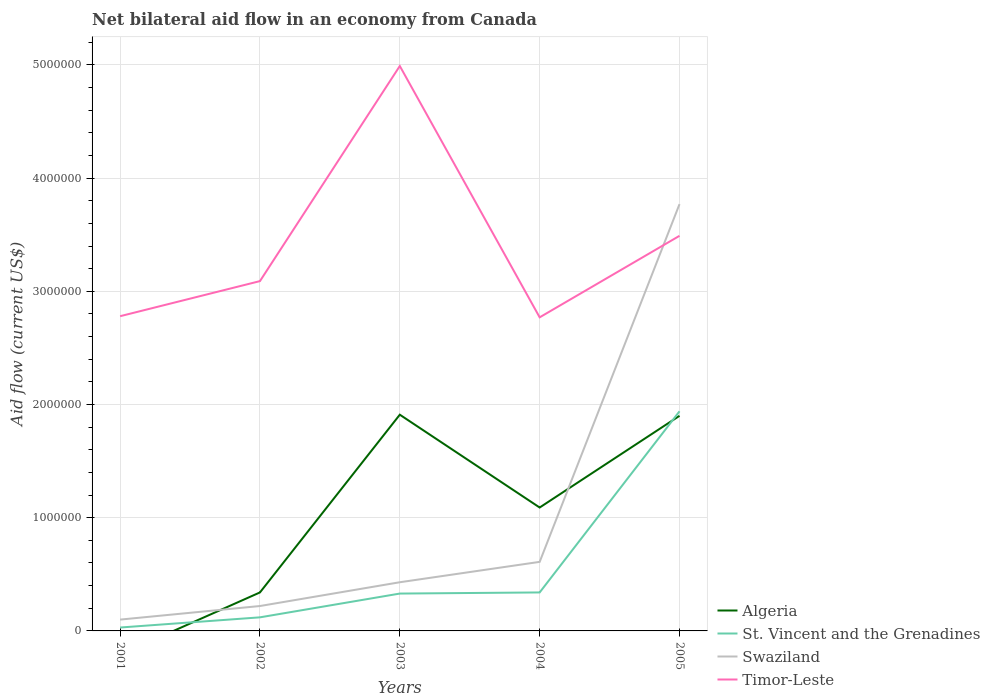How many different coloured lines are there?
Provide a short and direct response. 4. Is the number of lines equal to the number of legend labels?
Provide a short and direct response. No. Across all years, what is the maximum net bilateral aid flow in Swaziland?
Provide a succinct answer. 1.00e+05. What is the total net bilateral aid flow in St. Vincent and the Grenadines in the graph?
Offer a terse response. -3.10e+05. What is the difference between the highest and the second highest net bilateral aid flow in Algeria?
Your response must be concise. 1.91e+06. What is the difference between the highest and the lowest net bilateral aid flow in St. Vincent and the Grenadines?
Offer a very short reply. 1. Is the net bilateral aid flow in Timor-Leste strictly greater than the net bilateral aid flow in Algeria over the years?
Your answer should be compact. No. How many lines are there?
Make the answer very short. 4. How many years are there in the graph?
Offer a very short reply. 5. What is the difference between two consecutive major ticks on the Y-axis?
Give a very brief answer. 1.00e+06. Does the graph contain any zero values?
Provide a succinct answer. Yes. How many legend labels are there?
Give a very brief answer. 4. How are the legend labels stacked?
Ensure brevity in your answer.  Vertical. What is the title of the graph?
Make the answer very short. Net bilateral aid flow in an economy from Canada. Does "Cabo Verde" appear as one of the legend labels in the graph?
Provide a succinct answer. No. What is the Aid flow (current US$) in St. Vincent and the Grenadines in 2001?
Give a very brief answer. 3.00e+04. What is the Aid flow (current US$) of Swaziland in 2001?
Your answer should be compact. 1.00e+05. What is the Aid flow (current US$) in Timor-Leste in 2001?
Your answer should be very brief. 2.78e+06. What is the Aid flow (current US$) in Timor-Leste in 2002?
Your answer should be compact. 3.09e+06. What is the Aid flow (current US$) in Algeria in 2003?
Offer a very short reply. 1.91e+06. What is the Aid flow (current US$) of St. Vincent and the Grenadines in 2003?
Provide a short and direct response. 3.30e+05. What is the Aid flow (current US$) in Swaziland in 2003?
Your answer should be very brief. 4.30e+05. What is the Aid flow (current US$) in Timor-Leste in 2003?
Give a very brief answer. 4.99e+06. What is the Aid flow (current US$) of Algeria in 2004?
Give a very brief answer. 1.09e+06. What is the Aid flow (current US$) of St. Vincent and the Grenadines in 2004?
Provide a succinct answer. 3.40e+05. What is the Aid flow (current US$) in Swaziland in 2004?
Your answer should be very brief. 6.10e+05. What is the Aid flow (current US$) in Timor-Leste in 2004?
Make the answer very short. 2.77e+06. What is the Aid flow (current US$) in Algeria in 2005?
Give a very brief answer. 1.90e+06. What is the Aid flow (current US$) of St. Vincent and the Grenadines in 2005?
Your answer should be very brief. 1.94e+06. What is the Aid flow (current US$) in Swaziland in 2005?
Your response must be concise. 3.77e+06. What is the Aid flow (current US$) in Timor-Leste in 2005?
Your answer should be very brief. 3.49e+06. Across all years, what is the maximum Aid flow (current US$) of Algeria?
Provide a short and direct response. 1.91e+06. Across all years, what is the maximum Aid flow (current US$) of St. Vincent and the Grenadines?
Offer a very short reply. 1.94e+06. Across all years, what is the maximum Aid flow (current US$) of Swaziland?
Provide a short and direct response. 3.77e+06. Across all years, what is the maximum Aid flow (current US$) in Timor-Leste?
Ensure brevity in your answer.  4.99e+06. Across all years, what is the minimum Aid flow (current US$) of Algeria?
Offer a terse response. 0. Across all years, what is the minimum Aid flow (current US$) of St. Vincent and the Grenadines?
Your answer should be very brief. 3.00e+04. Across all years, what is the minimum Aid flow (current US$) in Swaziland?
Offer a very short reply. 1.00e+05. Across all years, what is the minimum Aid flow (current US$) of Timor-Leste?
Your answer should be compact. 2.77e+06. What is the total Aid flow (current US$) in Algeria in the graph?
Offer a very short reply. 5.24e+06. What is the total Aid flow (current US$) in St. Vincent and the Grenadines in the graph?
Keep it short and to the point. 2.76e+06. What is the total Aid flow (current US$) of Swaziland in the graph?
Your answer should be very brief. 5.13e+06. What is the total Aid flow (current US$) in Timor-Leste in the graph?
Provide a short and direct response. 1.71e+07. What is the difference between the Aid flow (current US$) of Timor-Leste in 2001 and that in 2002?
Ensure brevity in your answer.  -3.10e+05. What is the difference between the Aid flow (current US$) of Swaziland in 2001 and that in 2003?
Give a very brief answer. -3.30e+05. What is the difference between the Aid flow (current US$) in Timor-Leste in 2001 and that in 2003?
Your answer should be compact. -2.21e+06. What is the difference between the Aid flow (current US$) in St. Vincent and the Grenadines in 2001 and that in 2004?
Your answer should be compact. -3.10e+05. What is the difference between the Aid flow (current US$) of Swaziland in 2001 and that in 2004?
Offer a terse response. -5.10e+05. What is the difference between the Aid flow (current US$) of St. Vincent and the Grenadines in 2001 and that in 2005?
Your response must be concise. -1.91e+06. What is the difference between the Aid flow (current US$) of Swaziland in 2001 and that in 2005?
Your answer should be very brief. -3.67e+06. What is the difference between the Aid flow (current US$) in Timor-Leste in 2001 and that in 2005?
Offer a terse response. -7.10e+05. What is the difference between the Aid flow (current US$) of Algeria in 2002 and that in 2003?
Offer a very short reply. -1.57e+06. What is the difference between the Aid flow (current US$) in Timor-Leste in 2002 and that in 2003?
Keep it short and to the point. -1.90e+06. What is the difference between the Aid flow (current US$) in Algeria in 2002 and that in 2004?
Your answer should be compact. -7.50e+05. What is the difference between the Aid flow (current US$) of Swaziland in 2002 and that in 2004?
Ensure brevity in your answer.  -3.90e+05. What is the difference between the Aid flow (current US$) in Algeria in 2002 and that in 2005?
Your answer should be compact. -1.56e+06. What is the difference between the Aid flow (current US$) of St. Vincent and the Grenadines in 2002 and that in 2005?
Ensure brevity in your answer.  -1.82e+06. What is the difference between the Aid flow (current US$) of Swaziland in 2002 and that in 2005?
Make the answer very short. -3.55e+06. What is the difference between the Aid flow (current US$) in Timor-Leste in 2002 and that in 2005?
Your response must be concise. -4.00e+05. What is the difference between the Aid flow (current US$) in Algeria in 2003 and that in 2004?
Provide a short and direct response. 8.20e+05. What is the difference between the Aid flow (current US$) of Timor-Leste in 2003 and that in 2004?
Offer a very short reply. 2.22e+06. What is the difference between the Aid flow (current US$) in Algeria in 2003 and that in 2005?
Make the answer very short. 10000. What is the difference between the Aid flow (current US$) of St. Vincent and the Grenadines in 2003 and that in 2005?
Your answer should be very brief. -1.61e+06. What is the difference between the Aid flow (current US$) of Swaziland in 2003 and that in 2005?
Your answer should be very brief. -3.34e+06. What is the difference between the Aid flow (current US$) of Timor-Leste in 2003 and that in 2005?
Make the answer very short. 1.50e+06. What is the difference between the Aid flow (current US$) of Algeria in 2004 and that in 2005?
Give a very brief answer. -8.10e+05. What is the difference between the Aid flow (current US$) in St. Vincent and the Grenadines in 2004 and that in 2005?
Your response must be concise. -1.60e+06. What is the difference between the Aid flow (current US$) of Swaziland in 2004 and that in 2005?
Offer a very short reply. -3.16e+06. What is the difference between the Aid flow (current US$) of Timor-Leste in 2004 and that in 2005?
Your answer should be very brief. -7.20e+05. What is the difference between the Aid flow (current US$) in St. Vincent and the Grenadines in 2001 and the Aid flow (current US$) in Timor-Leste in 2002?
Provide a short and direct response. -3.06e+06. What is the difference between the Aid flow (current US$) in Swaziland in 2001 and the Aid flow (current US$) in Timor-Leste in 2002?
Ensure brevity in your answer.  -2.99e+06. What is the difference between the Aid flow (current US$) of St. Vincent and the Grenadines in 2001 and the Aid flow (current US$) of Swaziland in 2003?
Keep it short and to the point. -4.00e+05. What is the difference between the Aid flow (current US$) of St. Vincent and the Grenadines in 2001 and the Aid flow (current US$) of Timor-Leste in 2003?
Provide a succinct answer. -4.96e+06. What is the difference between the Aid flow (current US$) in Swaziland in 2001 and the Aid flow (current US$) in Timor-Leste in 2003?
Make the answer very short. -4.89e+06. What is the difference between the Aid flow (current US$) in St. Vincent and the Grenadines in 2001 and the Aid flow (current US$) in Swaziland in 2004?
Your answer should be compact. -5.80e+05. What is the difference between the Aid flow (current US$) of St. Vincent and the Grenadines in 2001 and the Aid flow (current US$) of Timor-Leste in 2004?
Keep it short and to the point. -2.74e+06. What is the difference between the Aid flow (current US$) in Swaziland in 2001 and the Aid flow (current US$) in Timor-Leste in 2004?
Your answer should be compact. -2.67e+06. What is the difference between the Aid flow (current US$) of St. Vincent and the Grenadines in 2001 and the Aid flow (current US$) of Swaziland in 2005?
Your response must be concise. -3.74e+06. What is the difference between the Aid flow (current US$) of St. Vincent and the Grenadines in 2001 and the Aid flow (current US$) of Timor-Leste in 2005?
Provide a short and direct response. -3.46e+06. What is the difference between the Aid flow (current US$) in Swaziland in 2001 and the Aid flow (current US$) in Timor-Leste in 2005?
Your answer should be very brief. -3.39e+06. What is the difference between the Aid flow (current US$) of Algeria in 2002 and the Aid flow (current US$) of Timor-Leste in 2003?
Your response must be concise. -4.65e+06. What is the difference between the Aid flow (current US$) in St. Vincent and the Grenadines in 2002 and the Aid flow (current US$) in Swaziland in 2003?
Offer a very short reply. -3.10e+05. What is the difference between the Aid flow (current US$) of St. Vincent and the Grenadines in 2002 and the Aid flow (current US$) of Timor-Leste in 2003?
Offer a terse response. -4.87e+06. What is the difference between the Aid flow (current US$) of Swaziland in 2002 and the Aid flow (current US$) of Timor-Leste in 2003?
Your answer should be very brief. -4.77e+06. What is the difference between the Aid flow (current US$) of Algeria in 2002 and the Aid flow (current US$) of St. Vincent and the Grenadines in 2004?
Make the answer very short. 0. What is the difference between the Aid flow (current US$) in Algeria in 2002 and the Aid flow (current US$) in Timor-Leste in 2004?
Offer a terse response. -2.43e+06. What is the difference between the Aid flow (current US$) in St. Vincent and the Grenadines in 2002 and the Aid flow (current US$) in Swaziland in 2004?
Ensure brevity in your answer.  -4.90e+05. What is the difference between the Aid flow (current US$) of St. Vincent and the Grenadines in 2002 and the Aid flow (current US$) of Timor-Leste in 2004?
Ensure brevity in your answer.  -2.65e+06. What is the difference between the Aid flow (current US$) in Swaziland in 2002 and the Aid flow (current US$) in Timor-Leste in 2004?
Provide a short and direct response. -2.55e+06. What is the difference between the Aid flow (current US$) in Algeria in 2002 and the Aid flow (current US$) in St. Vincent and the Grenadines in 2005?
Your answer should be compact. -1.60e+06. What is the difference between the Aid flow (current US$) of Algeria in 2002 and the Aid flow (current US$) of Swaziland in 2005?
Provide a short and direct response. -3.43e+06. What is the difference between the Aid flow (current US$) in Algeria in 2002 and the Aid flow (current US$) in Timor-Leste in 2005?
Ensure brevity in your answer.  -3.15e+06. What is the difference between the Aid flow (current US$) in St. Vincent and the Grenadines in 2002 and the Aid flow (current US$) in Swaziland in 2005?
Your response must be concise. -3.65e+06. What is the difference between the Aid flow (current US$) in St. Vincent and the Grenadines in 2002 and the Aid flow (current US$) in Timor-Leste in 2005?
Offer a very short reply. -3.37e+06. What is the difference between the Aid flow (current US$) of Swaziland in 2002 and the Aid flow (current US$) of Timor-Leste in 2005?
Your answer should be very brief. -3.27e+06. What is the difference between the Aid flow (current US$) in Algeria in 2003 and the Aid flow (current US$) in St. Vincent and the Grenadines in 2004?
Make the answer very short. 1.57e+06. What is the difference between the Aid flow (current US$) in Algeria in 2003 and the Aid flow (current US$) in Swaziland in 2004?
Provide a succinct answer. 1.30e+06. What is the difference between the Aid flow (current US$) in Algeria in 2003 and the Aid flow (current US$) in Timor-Leste in 2004?
Your response must be concise. -8.60e+05. What is the difference between the Aid flow (current US$) of St. Vincent and the Grenadines in 2003 and the Aid flow (current US$) of Swaziland in 2004?
Your answer should be compact. -2.80e+05. What is the difference between the Aid flow (current US$) in St. Vincent and the Grenadines in 2003 and the Aid flow (current US$) in Timor-Leste in 2004?
Make the answer very short. -2.44e+06. What is the difference between the Aid flow (current US$) of Swaziland in 2003 and the Aid flow (current US$) of Timor-Leste in 2004?
Ensure brevity in your answer.  -2.34e+06. What is the difference between the Aid flow (current US$) of Algeria in 2003 and the Aid flow (current US$) of Swaziland in 2005?
Give a very brief answer. -1.86e+06. What is the difference between the Aid flow (current US$) in Algeria in 2003 and the Aid flow (current US$) in Timor-Leste in 2005?
Your answer should be compact. -1.58e+06. What is the difference between the Aid flow (current US$) in St. Vincent and the Grenadines in 2003 and the Aid flow (current US$) in Swaziland in 2005?
Provide a succinct answer. -3.44e+06. What is the difference between the Aid flow (current US$) of St. Vincent and the Grenadines in 2003 and the Aid flow (current US$) of Timor-Leste in 2005?
Ensure brevity in your answer.  -3.16e+06. What is the difference between the Aid flow (current US$) in Swaziland in 2003 and the Aid flow (current US$) in Timor-Leste in 2005?
Provide a short and direct response. -3.06e+06. What is the difference between the Aid flow (current US$) of Algeria in 2004 and the Aid flow (current US$) of St. Vincent and the Grenadines in 2005?
Keep it short and to the point. -8.50e+05. What is the difference between the Aid flow (current US$) of Algeria in 2004 and the Aid flow (current US$) of Swaziland in 2005?
Make the answer very short. -2.68e+06. What is the difference between the Aid flow (current US$) in Algeria in 2004 and the Aid flow (current US$) in Timor-Leste in 2005?
Your answer should be compact. -2.40e+06. What is the difference between the Aid flow (current US$) of St. Vincent and the Grenadines in 2004 and the Aid flow (current US$) of Swaziland in 2005?
Give a very brief answer. -3.43e+06. What is the difference between the Aid flow (current US$) of St. Vincent and the Grenadines in 2004 and the Aid flow (current US$) of Timor-Leste in 2005?
Your response must be concise. -3.15e+06. What is the difference between the Aid flow (current US$) in Swaziland in 2004 and the Aid flow (current US$) in Timor-Leste in 2005?
Your response must be concise. -2.88e+06. What is the average Aid flow (current US$) in Algeria per year?
Make the answer very short. 1.05e+06. What is the average Aid flow (current US$) of St. Vincent and the Grenadines per year?
Offer a terse response. 5.52e+05. What is the average Aid flow (current US$) of Swaziland per year?
Provide a succinct answer. 1.03e+06. What is the average Aid flow (current US$) of Timor-Leste per year?
Offer a terse response. 3.42e+06. In the year 2001, what is the difference between the Aid flow (current US$) of St. Vincent and the Grenadines and Aid flow (current US$) of Timor-Leste?
Keep it short and to the point. -2.75e+06. In the year 2001, what is the difference between the Aid flow (current US$) in Swaziland and Aid flow (current US$) in Timor-Leste?
Make the answer very short. -2.68e+06. In the year 2002, what is the difference between the Aid flow (current US$) in Algeria and Aid flow (current US$) in St. Vincent and the Grenadines?
Give a very brief answer. 2.20e+05. In the year 2002, what is the difference between the Aid flow (current US$) in Algeria and Aid flow (current US$) in Swaziland?
Your answer should be very brief. 1.20e+05. In the year 2002, what is the difference between the Aid flow (current US$) of Algeria and Aid flow (current US$) of Timor-Leste?
Keep it short and to the point. -2.75e+06. In the year 2002, what is the difference between the Aid flow (current US$) of St. Vincent and the Grenadines and Aid flow (current US$) of Timor-Leste?
Give a very brief answer. -2.97e+06. In the year 2002, what is the difference between the Aid flow (current US$) in Swaziland and Aid flow (current US$) in Timor-Leste?
Give a very brief answer. -2.87e+06. In the year 2003, what is the difference between the Aid flow (current US$) in Algeria and Aid flow (current US$) in St. Vincent and the Grenadines?
Provide a short and direct response. 1.58e+06. In the year 2003, what is the difference between the Aid flow (current US$) in Algeria and Aid flow (current US$) in Swaziland?
Ensure brevity in your answer.  1.48e+06. In the year 2003, what is the difference between the Aid flow (current US$) of Algeria and Aid flow (current US$) of Timor-Leste?
Your answer should be very brief. -3.08e+06. In the year 2003, what is the difference between the Aid flow (current US$) of St. Vincent and the Grenadines and Aid flow (current US$) of Timor-Leste?
Make the answer very short. -4.66e+06. In the year 2003, what is the difference between the Aid flow (current US$) of Swaziland and Aid flow (current US$) of Timor-Leste?
Offer a terse response. -4.56e+06. In the year 2004, what is the difference between the Aid flow (current US$) in Algeria and Aid flow (current US$) in St. Vincent and the Grenadines?
Your response must be concise. 7.50e+05. In the year 2004, what is the difference between the Aid flow (current US$) in Algeria and Aid flow (current US$) in Swaziland?
Ensure brevity in your answer.  4.80e+05. In the year 2004, what is the difference between the Aid flow (current US$) of Algeria and Aid flow (current US$) of Timor-Leste?
Make the answer very short. -1.68e+06. In the year 2004, what is the difference between the Aid flow (current US$) of St. Vincent and the Grenadines and Aid flow (current US$) of Swaziland?
Provide a succinct answer. -2.70e+05. In the year 2004, what is the difference between the Aid flow (current US$) in St. Vincent and the Grenadines and Aid flow (current US$) in Timor-Leste?
Provide a short and direct response. -2.43e+06. In the year 2004, what is the difference between the Aid flow (current US$) of Swaziland and Aid flow (current US$) of Timor-Leste?
Provide a short and direct response. -2.16e+06. In the year 2005, what is the difference between the Aid flow (current US$) in Algeria and Aid flow (current US$) in St. Vincent and the Grenadines?
Your answer should be compact. -4.00e+04. In the year 2005, what is the difference between the Aid flow (current US$) in Algeria and Aid flow (current US$) in Swaziland?
Provide a short and direct response. -1.87e+06. In the year 2005, what is the difference between the Aid flow (current US$) in Algeria and Aid flow (current US$) in Timor-Leste?
Make the answer very short. -1.59e+06. In the year 2005, what is the difference between the Aid flow (current US$) in St. Vincent and the Grenadines and Aid flow (current US$) in Swaziland?
Your answer should be very brief. -1.83e+06. In the year 2005, what is the difference between the Aid flow (current US$) of St. Vincent and the Grenadines and Aid flow (current US$) of Timor-Leste?
Your answer should be compact. -1.55e+06. What is the ratio of the Aid flow (current US$) of St. Vincent and the Grenadines in 2001 to that in 2002?
Provide a succinct answer. 0.25. What is the ratio of the Aid flow (current US$) in Swaziland in 2001 to that in 2002?
Your response must be concise. 0.45. What is the ratio of the Aid flow (current US$) of Timor-Leste in 2001 to that in 2002?
Your answer should be compact. 0.9. What is the ratio of the Aid flow (current US$) in St. Vincent and the Grenadines in 2001 to that in 2003?
Provide a succinct answer. 0.09. What is the ratio of the Aid flow (current US$) in Swaziland in 2001 to that in 2003?
Offer a very short reply. 0.23. What is the ratio of the Aid flow (current US$) in Timor-Leste in 2001 to that in 2003?
Ensure brevity in your answer.  0.56. What is the ratio of the Aid flow (current US$) of St. Vincent and the Grenadines in 2001 to that in 2004?
Give a very brief answer. 0.09. What is the ratio of the Aid flow (current US$) of Swaziland in 2001 to that in 2004?
Provide a short and direct response. 0.16. What is the ratio of the Aid flow (current US$) of St. Vincent and the Grenadines in 2001 to that in 2005?
Give a very brief answer. 0.02. What is the ratio of the Aid flow (current US$) of Swaziland in 2001 to that in 2005?
Offer a very short reply. 0.03. What is the ratio of the Aid flow (current US$) of Timor-Leste in 2001 to that in 2005?
Provide a short and direct response. 0.8. What is the ratio of the Aid flow (current US$) in Algeria in 2002 to that in 2003?
Give a very brief answer. 0.18. What is the ratio of the Aid flow (current US$) of St. Vincent and the Grenadines in 2002 to that in 2003?
Your answer should be compact. 0.36. What is the ratio of the Aid flow (current US$) in Swaziland in 2002 to that in 2003?
Your answer should be compact. 0.51. What is the ratio of the Aid flow (current US$) in Timor-Leste in 2002 to that in 2003?
Make the answer very short. 0.62. What is the ratio of the Aid flow (current US$) of Algeria in 2002 to that in 2004?
Give a very brief answer. 0.31. What is the ratio of the Aid flow (current US$) in St. Vincent and the Grenadines in 2002 to that in 2004?
Your answer should be compact. 0.35. What is the ratio of the Aid flow (current US$) in Swaziland in 2002 to that in 2004?
Offer a very short reply. 0.36. What is the ratio of the Aid flow (current US$) of Timor-Leste in 2002 to that in 2004?
Make the answer very short. 1.12. What is the ratio of the Aid flow (current US$) of Algeria in 2002 to that in 2005?
Provide a short and direct response. 0.18. What is the ratio of the Aid flow (current US$) in St. Vincent and the Grenadines in 2002 to that in 2005?
Offer a very short reply. 0.06. What is the ratio of the Aid flow (current US$) of Swaziland in 2002 to that in 2005?
Offer a terse response. 0.06. What is the ratio of the Aid flow (current US$) of Timor-Leste in 2002 to that in 2005?
Provide a succinct answer. 0.89. What is the ratio of the Aid flow (current US$) in Algeria in 2003 to that in 2004?
Ensure brevity in your answer.  1.75. What is the ratio of the Aid flow (current US$) in St. Vincent and the Grenadines in 2003 to that in 2004?
Offer a very short reply. 0.97. What is the ratio of the Aid flow (current US$) in Swaziland in 2003 to that in 2004?
Keep it short and to the point. 0.7. What is the ratio of the Aid flow (current US$) of Timor-Leste in 2003 to that in 2004?
Make the answer very short. 1.8. What is the ratio of the Aid flow (current US$) in St. Vincent and the Grenadines in 2003 to that in 2005?
Ensure brevity in your answer.  0.17. What is the ratio of the Aid flow (current US$) of Swaziland in 2003 to that in 2005?
Provide a short and direct response. 0.11. What is the ratio of the Aid flow (current US$) of Timor-Leste in 2003 to that in 2005?
Your answer should be compact. 1.43. What is the ratio of the Aid flow (current US$) of Algeria in 2004 to that in 2005?
Offer a terse response. 0.57. What is the ratio of the Aid flow (current US$) of St. Vincent and the Grenadines in 2004 to that in 2005?
Your answer should be compact. 0.18. What is the ratio of the Aid flow (current US$) in Swaziland in 2004 to that in 2005?
Provide a succinct answer. 0.16. What is the ratio of the Aid flow (current US$) of Timor-Leste in 2004 to that in 2005?
Your answer should be compact. 0.79. What is the difference between the highest and the second highest Aid flow (current US$) of Algeria?
Offer a terse response. 10000. What is the difference between the highest and the second highest Aid flow (current US$) in St. Vincent and the Grenadines?
Ensure brevity in your answer.  1.60e+06. What is the difference between the highest and the second highest Aid flow (current US$) in Swaziland?
Ensure brevity in your answer.  3.16e+06. What is the difference between the highest and the second highest Aid flow (current US$) in Timor-Leste?
Your answer should be compact. 1.50e+06. What is the difference between the highest and the lowest Aid flow (current US$) of Algeria?
Provide a succinct answer. 1.91e+06. What is the difference between the highest and the lowest Aid flow (current US$) in St. Vincent and the Grenadines?
Offer a terse response. 1.91e+06. What is the difference between the highest and the lowest Aid flow (current US$) in Swaziland?
Provide a short and direct response. 3.67e+06. What is the difference between the highest and the lowest Aid flow (current US$) of Timor-Leste?
Your answer should be compact. 2.22e+06. 